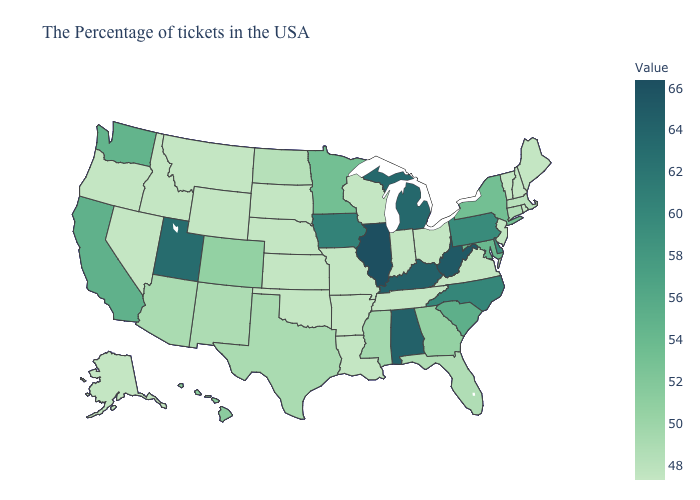Which states have the lowest value in the Northeast?
Give a very brief answer. Maine, Rhode Island, New Hampshire, Vermont. Which states have the lowest value in the USA?
Short answer required. Maine, Rhode Island, New Hampshire, Vermont, Virginia, Ohio, Indiana, Tennessee, Wisconsin, Louisiana, Missouri, Arkansas, Kansas, Nebraska, Oklahoma, South Dakota, Wyoming, Montana, Idaho, Nevada, Oregon, Alaska. Which states have the lowest value in the USA?
Keep it brief. Maine, Rhode Island, New Hampshire, Vermont, Virginia, Ohio, Indiana, Tennessee, Wisconsin, Louisiana, Missouri, Arkansas, Kansas, Nebraska, Oklahoma, South Dakota, Wyoming, Montana, Idaho, Nevada, Oregon, Alaska. Among the states that border Rhode Island , does Massachusetts have the highest value?
Short answer required. No. Which states have the lowest value in the USA?
Concise answer only. Maine, Rhode Island, New Hampshire, Vermont, Virginia, Ohio, Indiana, Tennessee, Wisconsin, Louisiana, Missouri, Arkansas, Kansas, Nebraska, Oklahoma, South Dakota, Wyoming, Montana, Idaho, Nevada, Oregon, Alaska. Among the states that border Florida , which have the lowest value?
Keep it brief. Georgia. 